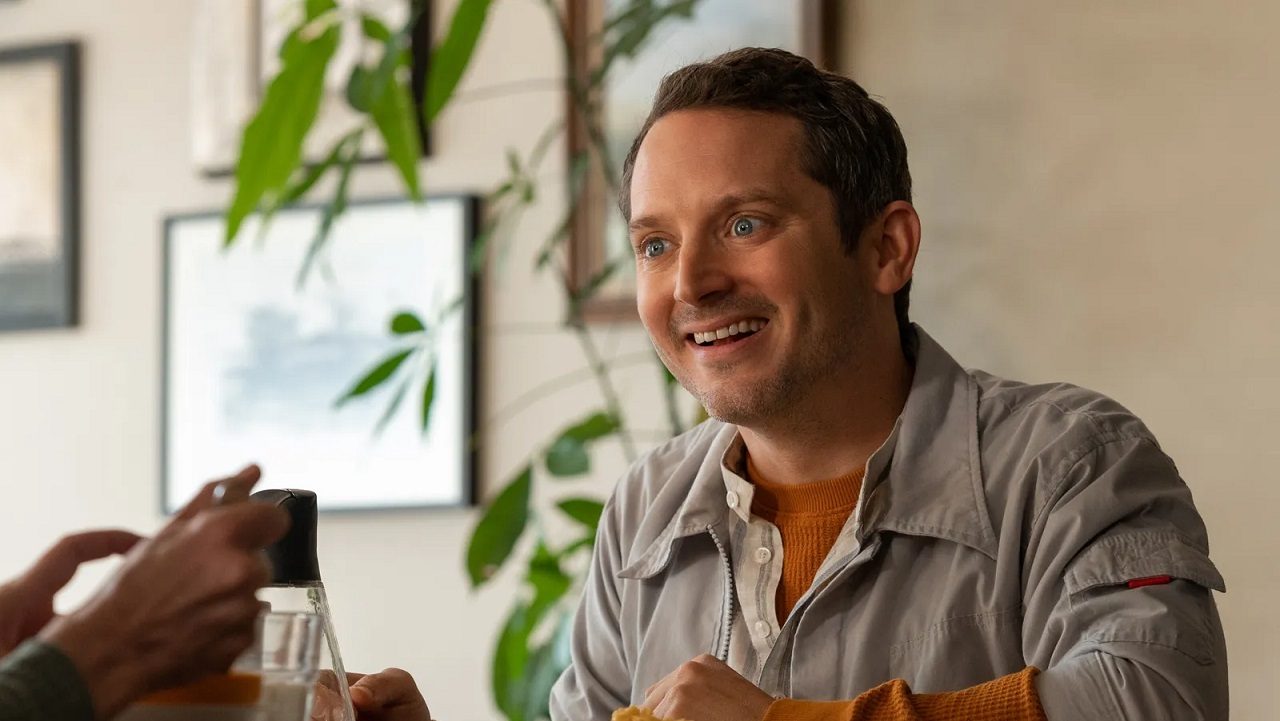Can you describe the emotions conveyed by the person in the image? The person in the image conveys a sense of genuine happiness and engagement. His wide smile and bright eyes suggest he is enjoying the moment, likely immersed in a pleasant and friendly interaction. The relaxed posture and open expression further indicate a convivial and joyful atmosphere. 